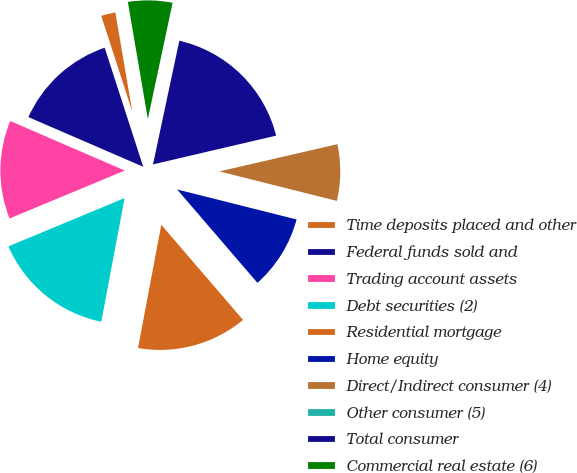<chart> <loc_0><loc_0><loc_500><loc_500><pie_chart><fcel>Time deposits placed and other<fcel>Federal funds sold and<fcel>Trading account assets<fcel>Debt securities (2)<fcel>Residential mortgage<fcel>Home equity<fcel>Direct/Indirect consumer (4)<fcel>Other consumer (5)<fcel>Total consumer<fcel>Commercial real estate (6)<nl><fcel>2.29%<fcel>13.52%<fcel>12.77%<fcel>15.76%<fcel>14.27%<fcel>9.78%<fcel>7.53%<fcel>0.04%<fcel>18.01%<fcel>6.03%<nl></chart> 